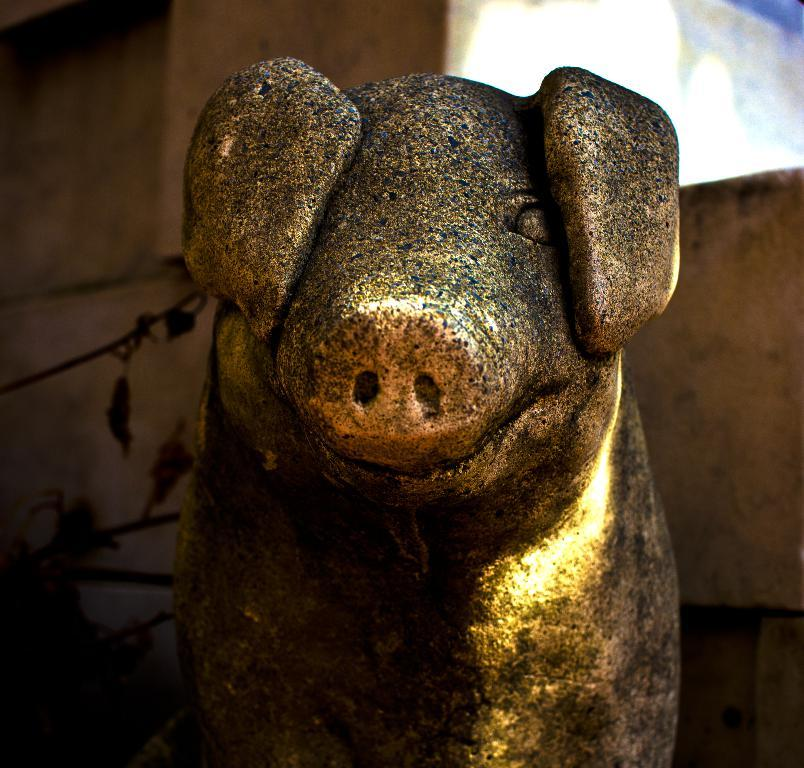What is the main subject in the foreground of the image? There is a pig sculpture in the foreground of the image. What can be seen behind the pig sculpture? There appears to be a wall behind the pig sculpture. What type of vegetation is visible on the left side of the image? There are leaves visible on the left side of the image. Where is the engine located in the image? There is no engine present in the image. What type of bear can be seen sitting on the shelf in the image? There is no bear or shelf present in the image. 